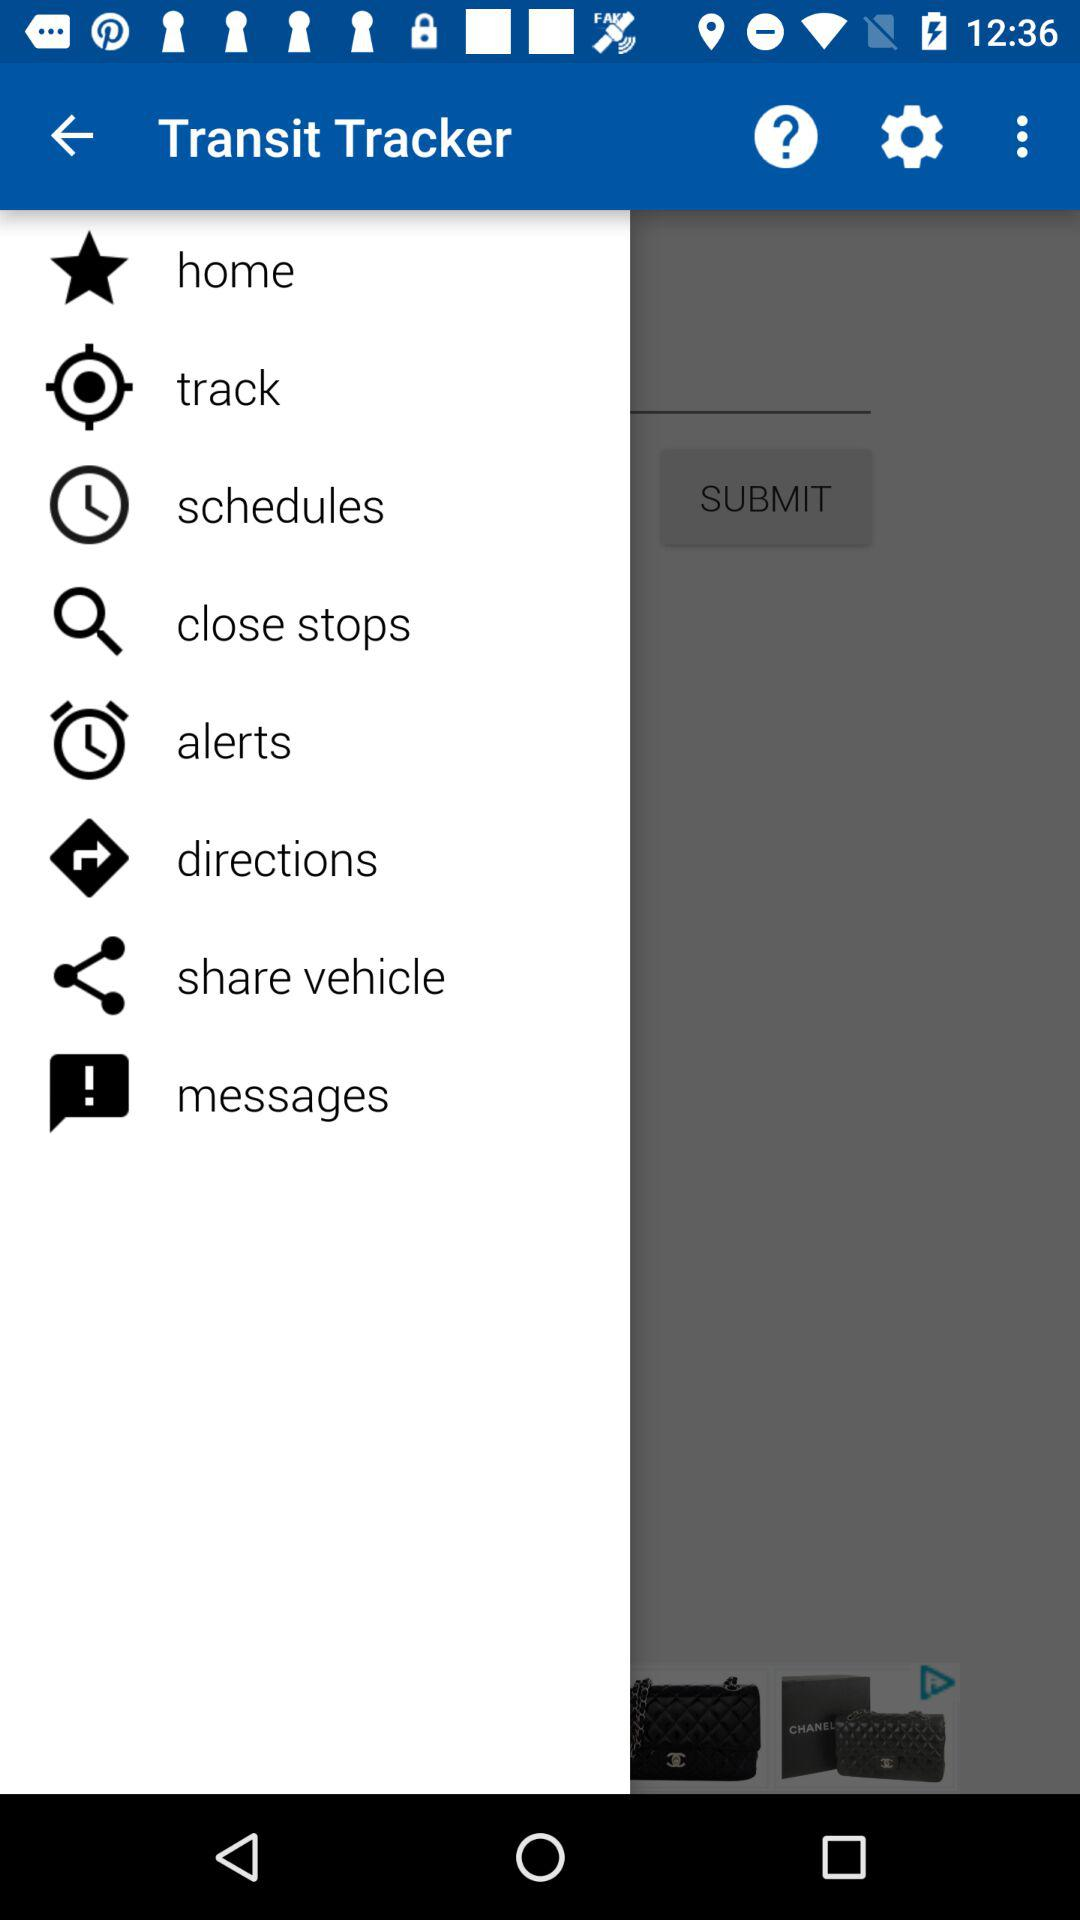What is the name of the application? The application name is "Transit Tracker". 